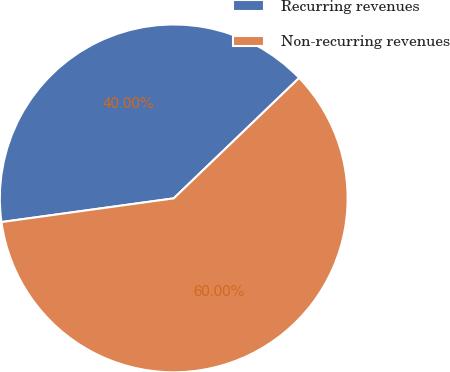Convert chart to OTSL. <chart><loc_0><loc_0><loc_500><loc_500><pie_chart><fcel>Recurring revenues<fcel>Non-recurring revenues<nl><fcel>40.0%<fcel>60.0%<nl></chart> 